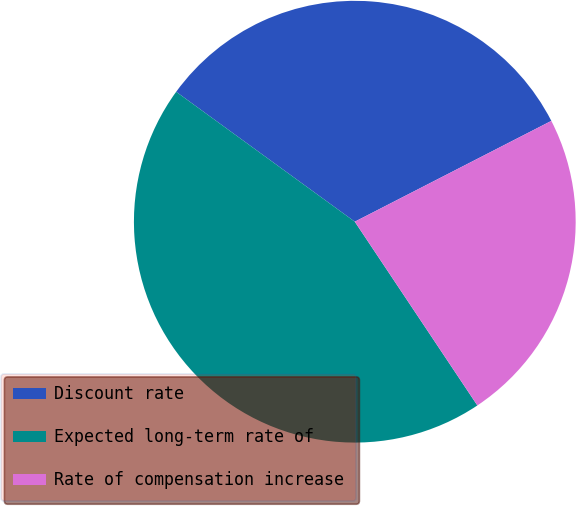Convert chart to OTSL. <chart><loc_0><loc_0><loc_500><loc_500><pie_chart><fcel>Discount rate<fcel>Expected long-term rate of<fcel>Rate of compensation increase<nl><fcel>32.45%<fcel>44.37%<fcel>23.18%<nl></chart> 